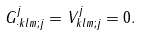Convert formula to latex. <formula><loc_0><loc_0><loc_500><loc_500>G _ { \cdot k l m ; j } ^ { j } = V _ { k l m ; j } ^ { j } = 0 .</formula> 